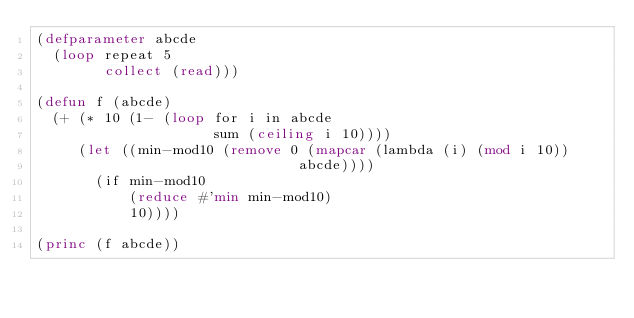Convert code to text. <code><loc_0><loc_0><loc_500><loc_500><_Lisp_>(defparameter abcde
  (loop repeat 5
        collect (read)))

(defun f (abcde)
  (+ (* 10 (1- (loop for i in abcde
                     sum (ceiling i 10))))
     (let ((min-mod10 (remove 0 (mapcar (lambda (i) (mod i 10))
                               abcde))))
       (if min-mod10
           (reduce #'min min-mod10)
           10))))

(princ (f abcde))
</code> 